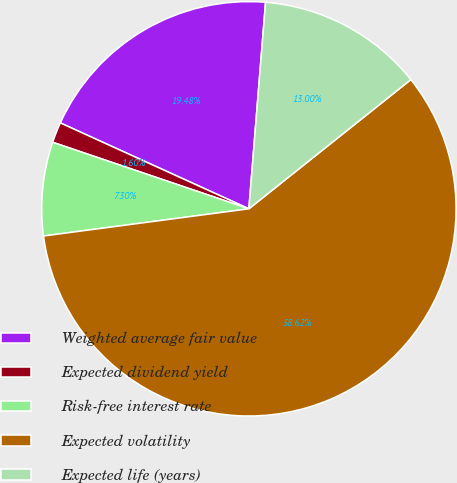Convert chart. <chart><loc_0><loc_0><loc_500><loc_500><pie_chart><fcel>Weighted average fair value<fcel>Expected dividend yield<fcel>Risk-free interest rate<fcel>Expected volatility<fcel>Expected life (years)<nl><fcel>19.48%<fcel>1.6%<fcel>7.3%<fcel>58.62%<fcel>13.0%<nl></chart> 